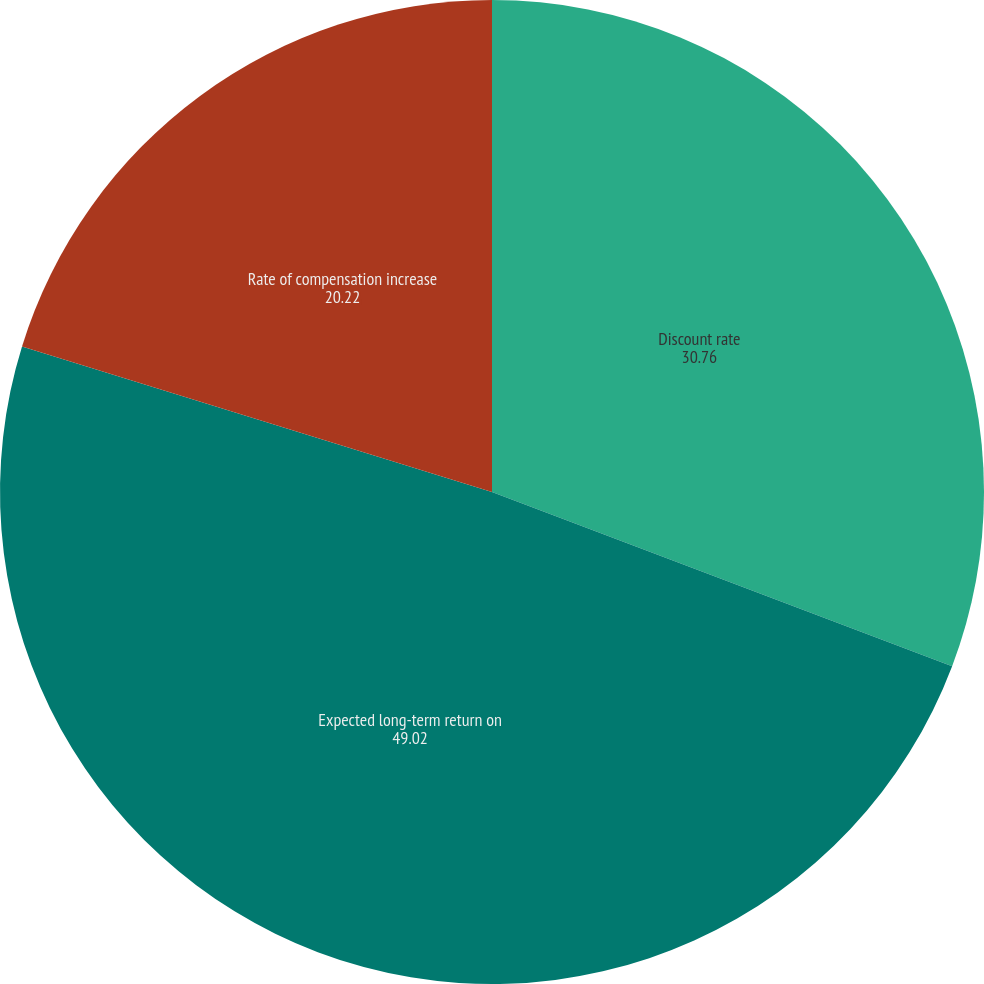<chart> <loc_0><loc_0><loc_500><loc_500><pie_chart><fcel>Discount rate<fcel>Expected long-term return on<fcel>Rate of compensation increase<nl><fcel>30.76%<fcel>49.02%<fcel>20.22%<nl></chart> 